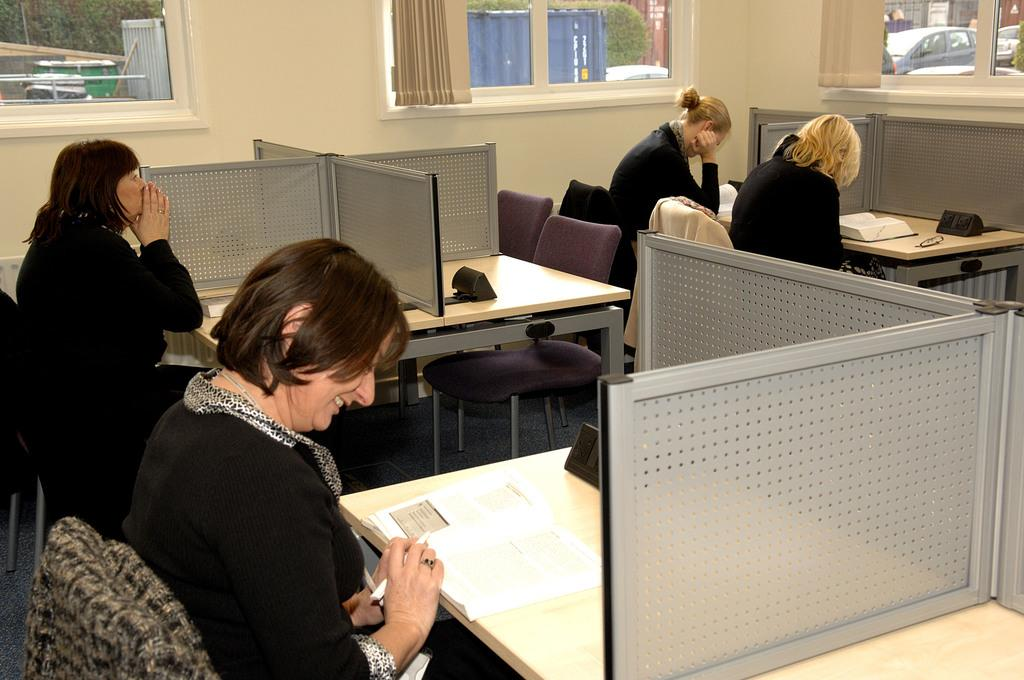Who is present in the image? There are people in the image. What are the people doing in the image? The people are seated on chairs and reading books. What type of pancake is being served to the people in the image? There is no pancake present in the image; the people are reading books. Can you tell me how the people's anger is being expressed in the image? There is no indication of anger in the image; the people are reading books calmly. 